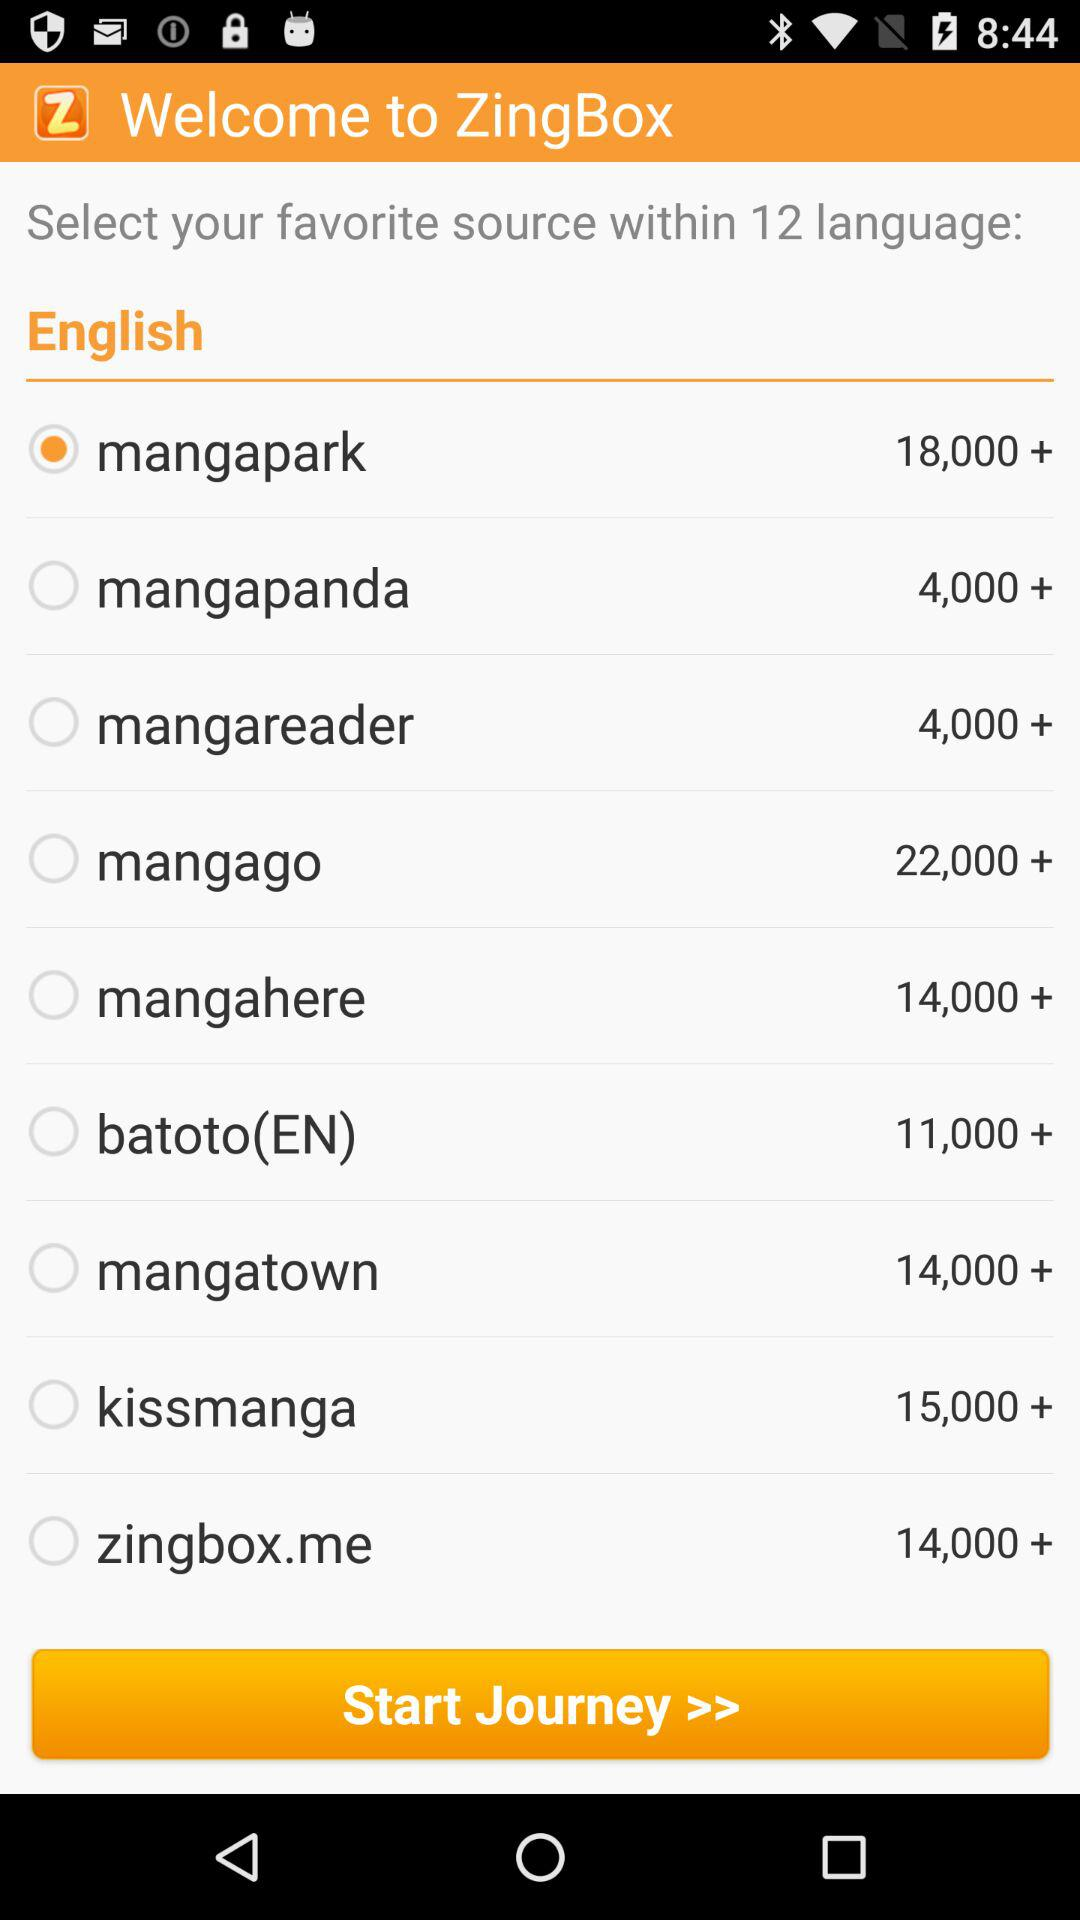Which source has 13,000+ manga?
When the provided information is insufficient, respond with <no answer>. <no answer> 